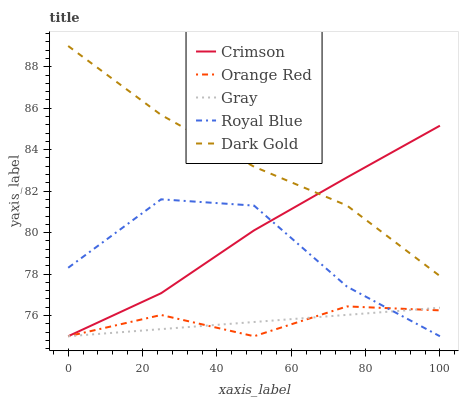Does Dark Gold have the minimum area under the curve?
Answer yes or no. No. Does Gray have the maximum area under the curve?
Answer yes or no. No. Is Dark Gold the smoothest?
Answer yes or no. No. Is Dark Gold the roughest?
Answer yes or no. No. Does Dark Gold have the lowest value?
Answer yes or no. No. Does Gray have the highest value?
Answer yes or no. No. Is Gray less than Dark Gold?
Answer yes or no. Yes. Is Dark Gold greater than Orange Red?
Answer yes or no. Yes. Does Gray intersect Dark Gold?
Answer yes or no. No. 